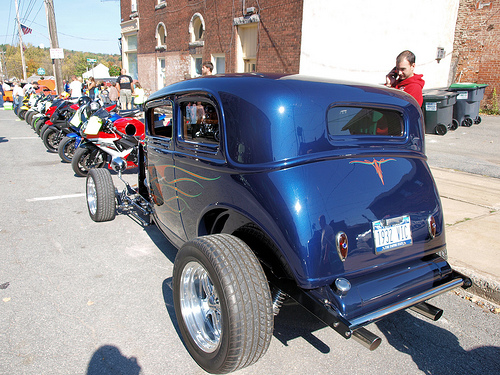<image>
Is the man behind the car? Yes. From this viewpoint, the man is positioned behind the car, with the car partially or fully occluding the man. 